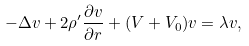Convert formula to latex. <formula><loc_0><loc_0><loc_500><loc_500>- \Delta v + 2 \rho ^ { \prime } \frac { \partial v } { \partial r } + ( V + V _ { 0 } ) v = \lambda v ,</formula> 